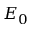Convert formula to latex. <formula><loc_0><loc_0><loc_500><loc_500>E _ { 0 }</formula> 